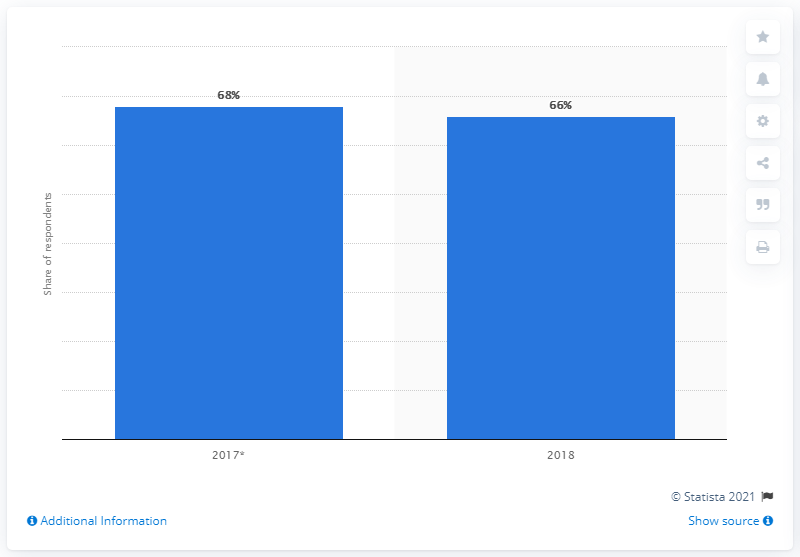Draw attention to some important aspects in this diagram. In 2017, WhatsApp had the highest number of users. The average of two years is 67. 